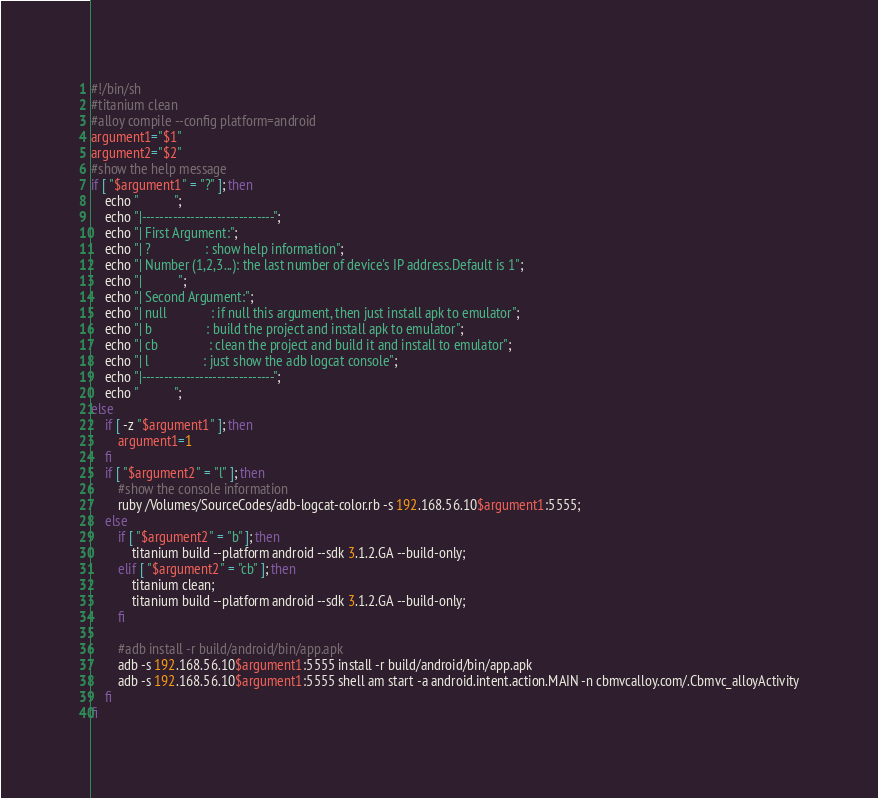Convert code to text. <code><loc_0><loc_0><loc_500><loc_500><_Bash_>
#!/bin/sh
#titanium clean
#alloy compile --config platform=android
argument1="$1"
argument2="$2"
#show the help message
if [ "$argument1" = "?" ]; then
    echo "           ";
    echo "|------------------------------";
    echo "| First Argument:";
    echo "| ?                : show help information";
    echo "| Number (1,2,3...): the last number of device's IP address.Default is 1";
    echo "|           ";
    echo "| Second Argument:";
    echo "| null             : if null this argument, then just install apk to emulator";
    echo "| b                : build the project and install apk to emulator";
    echo "| cb               : clean the project and build it and install to emulator";
    echo "| l                : just show the adb logcat console";
    echo "|------------------------------";
    echo "           ";
else
    if [ -z "$argument1" ]; then
        argument1=1
    fi
    if [ "$argument2" = "l" ]; then
        #show the console information
        ruby /Volumes/SourceCodes/adb-logcat-color.rb -s 192.168.56.10$argument1:5555;
    else
        if [ "$argument2" = "b" ]; then
            titanium build --platform android --sdk 3.1.2.GA --build-only;
        elif [ "$argument2" = "cb" ]; then
            titanium clean;
            titanium build --platform android --sdk 3.1.2.GA --build-only;
        fi

        #adb install -r build/android/bin/app.apk
        adb -s 192.168.56.10$argument1:5555 install -r build/android/bin/app.apk
        adb -s 192.168.56.10$argument1:5555 shell am start -a android.intent.action.MAIN -n cbmvcalloy.com/.Cbmvc_alloyActivity
    fi
fi
</code> 